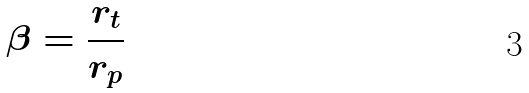Convert formula to latex. <formula><loc_0><loc_0><loc_500><loc_500>\beta = \frac { r _ { t } } { r _ { p } }</formula> 